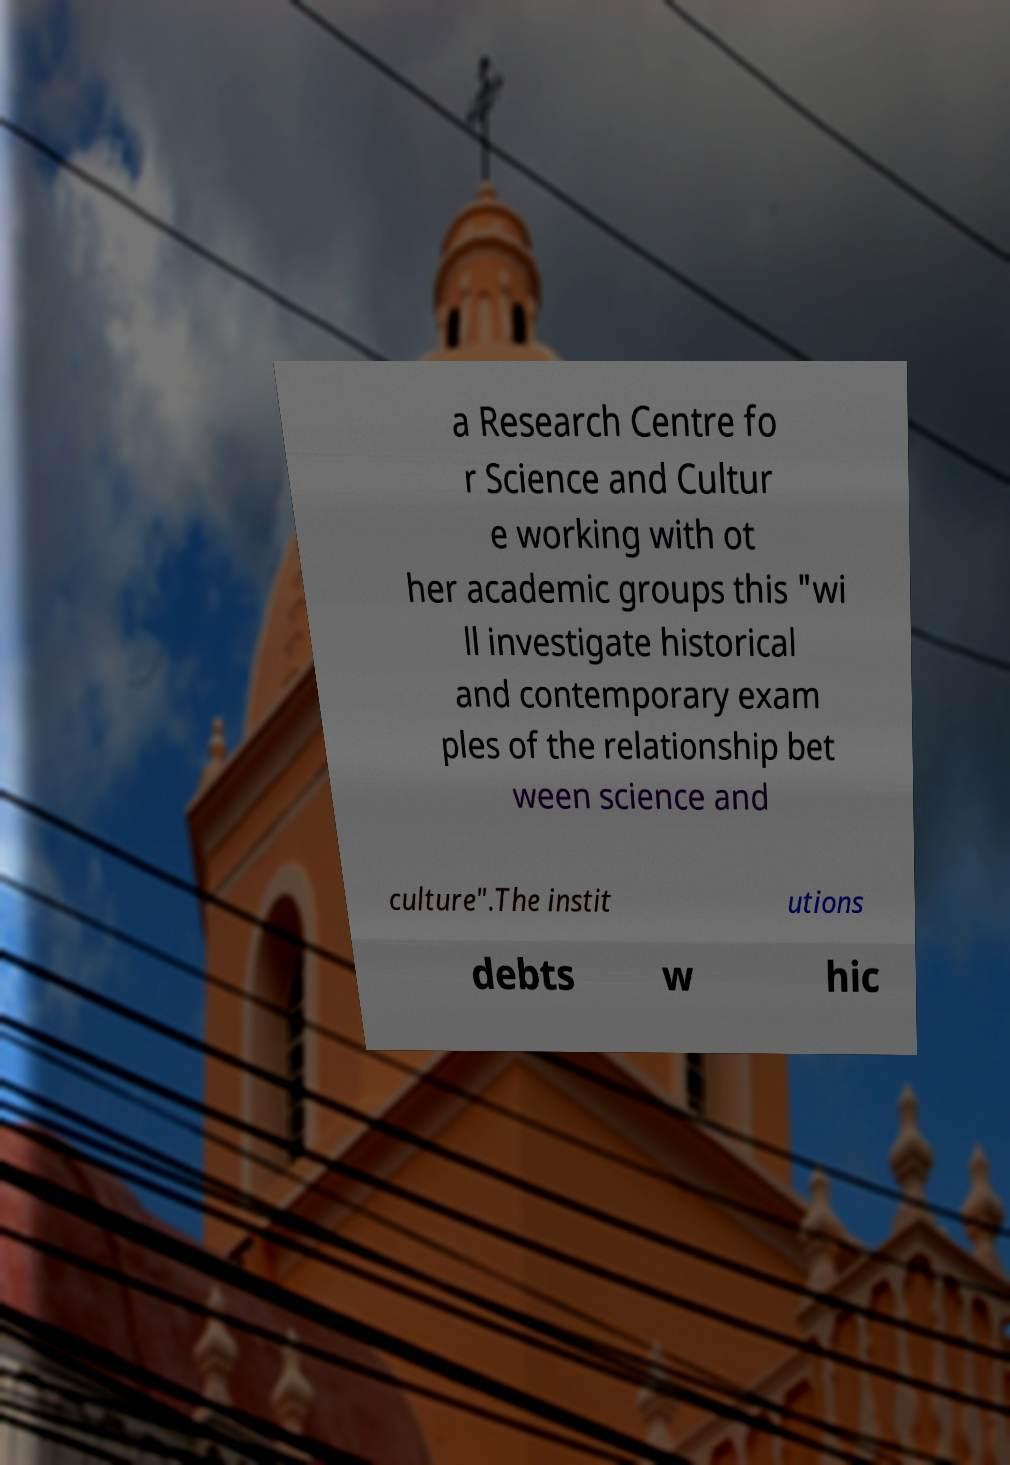For documentation purposes, I need the text within this image transcribed. Could you provide that? a Research Centre fo r Science and Cultur e working with ot her academic groups this "wi ll investigate historical and contemporary exam ples of the relationship bet ween science and culture".The instit utions debts w hic 